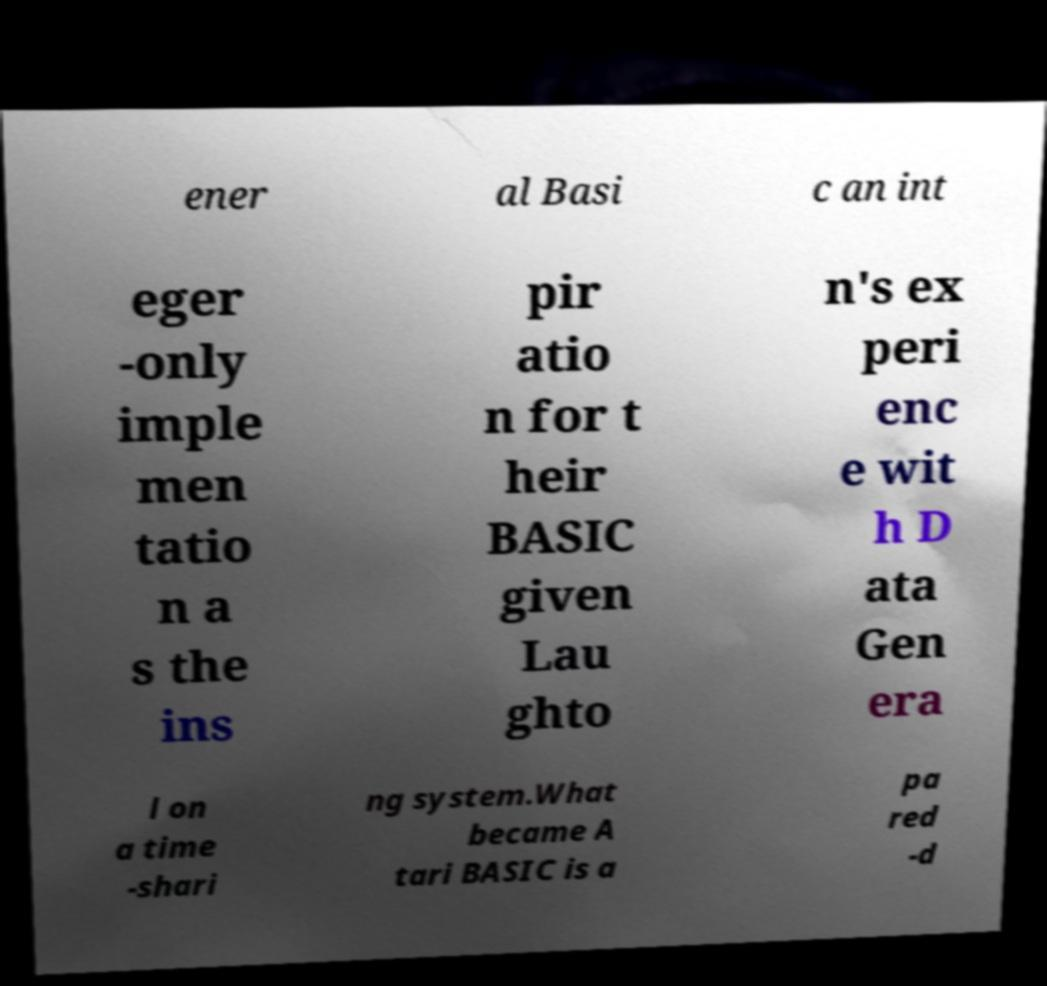For documentation purposes, I need the text within this image transcribed. Could you provide that? ener al Basi c an int eger -only imple men tatio n a s the ins pir atio n for t heir BASIC given Lau ghto n's ex peri enc e wit h D ata Gen era l on a time -shari ng system.What became A tari BASIC is a pa red -d 